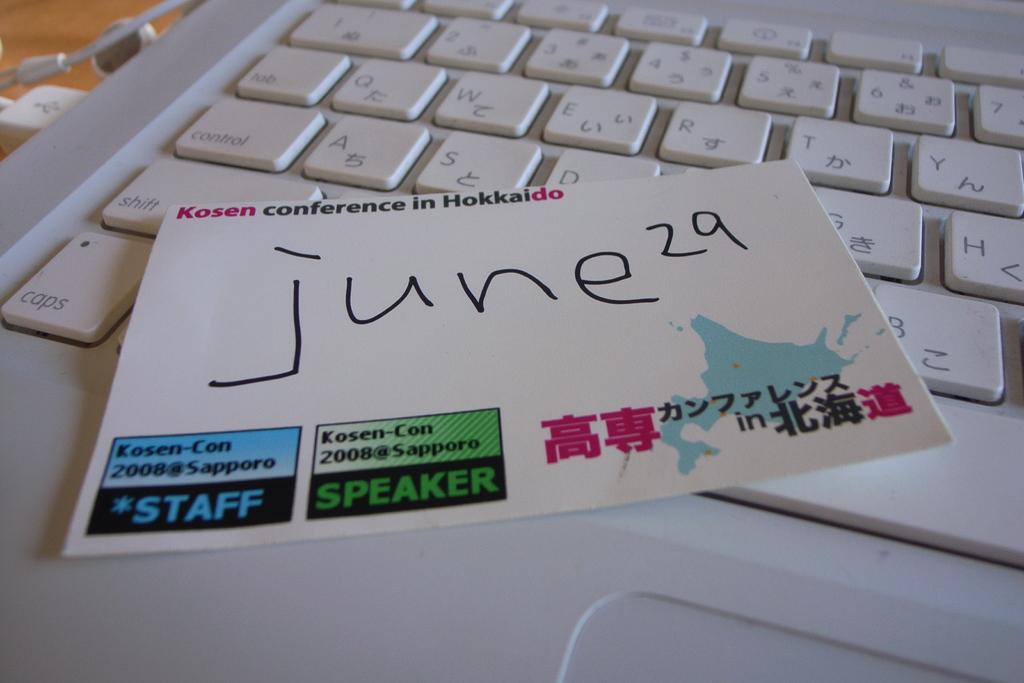What month is written on this card?
Ensure brevity in your answer.  June. What does the blue text say on the bottom left?
Make the answer very short. Staff. 